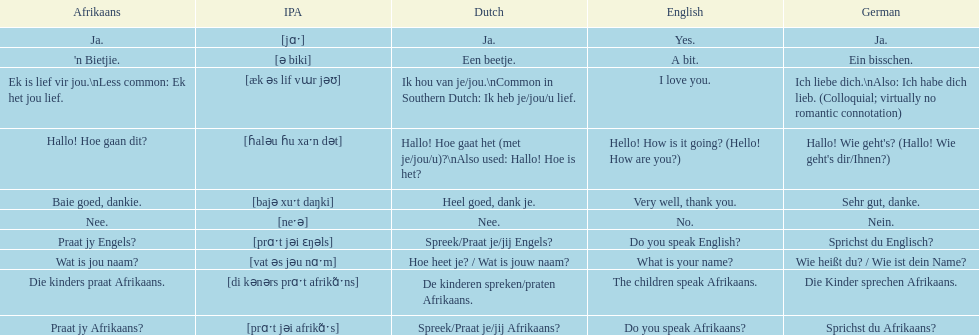How do you say 'i love you' in afrikaans? Ek is lief vir jou. 